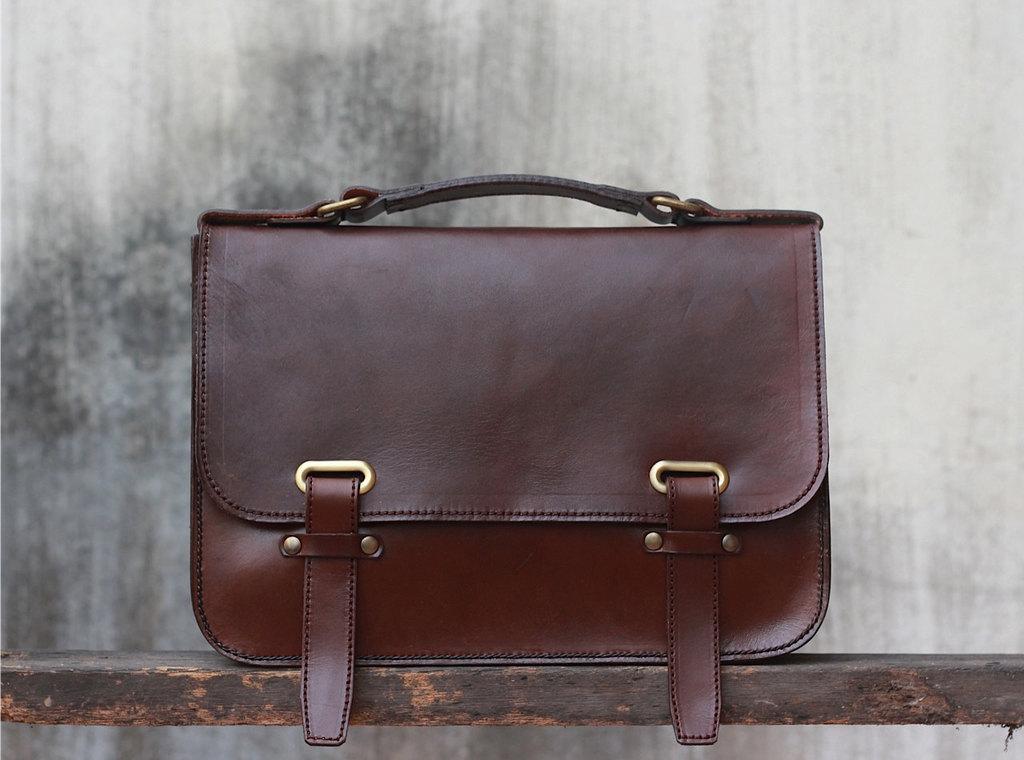How would you summarize this image in a sentence or two? This is a picture of a handbag where there is a handle , hook and the handbag is made of leather in the wooden rack. 